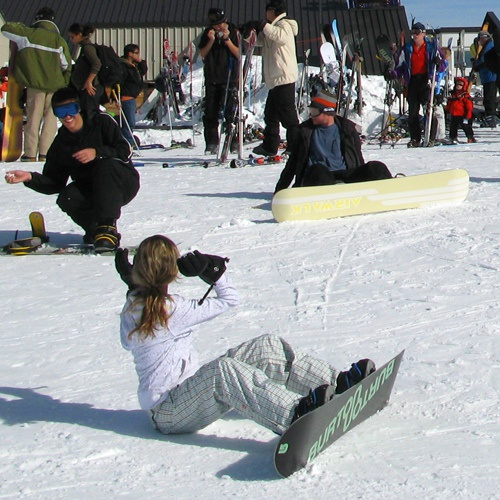Describe the objects in this image and their specific colors. I can see people in black, gray, lightgray, and darkgray tones, people in black, brown, gray, and navy tones, snowboard in black, khaki, beige, and darkgray tones, people in black, darkblue, gray, and navy tones, and people in black, darkgreen, tan, and gray tones in this image. 